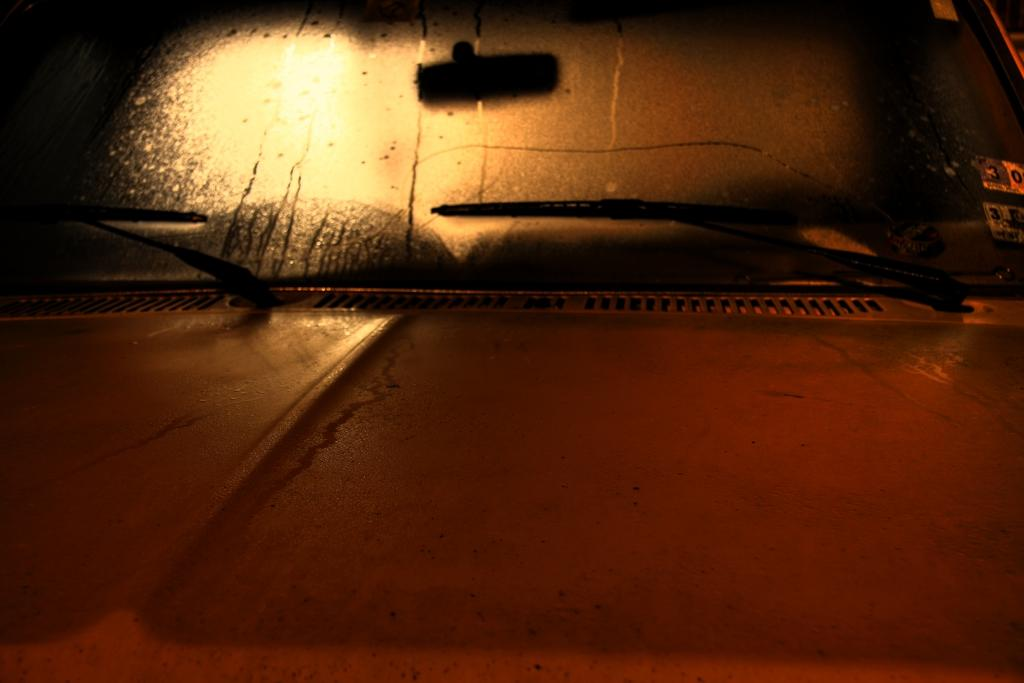What is the main subject of the image? There is a vehicle in the image. How is the vehicle shown in the image? The vehicle is shown from the front. What else can be seen in the image besides the vehicle? There are objects visible in the image. What decorative elements are present on the vehicle? There are stickers on the glass of the vehicle. What sense is being used by the vehicle in the image? Vehicles do not have senses, as they are inanimate objects. --- Facts: 1. There is a person in the image. 2. The person is wearing a hat. 3. The person is holding a book. 4. There is a table in the image. 5. The table has a lamp on it. Absurd Topics: dance, ocean, instrument Conversation: Who is the main subject of the image? There is a person in the image. What is the person wearing? The person is wearing a hat. What is the person holding? The person is holding a book. What is present on the table in the image? There is a table in the image, and it has a lamp on it. Reasoning: Let's think step by step in order to produce the conversation. We start by identifying the main subject of the image, which is the person. Then, we describe what the person is wearing and holding to provide more details about their appearance and actions. Next, we mention the presence of a table and its contents, which is a lamp. Absurd Question/Answer: What type of dance is the person performing in the image? There is no indication of dancing in the image; the person is simply holding a book. --- Facts: 1. There is a group of people in the image. 2. The people are wearing uniforms. 3. The people are holding musical instruments. 4. There is a stage in the image. 5. The stage has a microphone on it. Absurd Topics: snow, mountain, animal Conversation: Who are the main subjects of the image? There is a group of people in the image. What are the people wearing? The people are wearing uniforms. What are the people holding? The people are holding musical instruments. What is present on the stage in the image? There is a stage in the image, and it has a microphone on it. Reasoning: Let's think step by step in order to produce the conversation. We start by identifying the main subjects of the image, which is the group of people. Then, we describe what the people are wearing and holding to provide more details about their appearance and actions. Next, we mention the presence of a stage and its contents, which is a microphone. Absurd Question/Answer: 